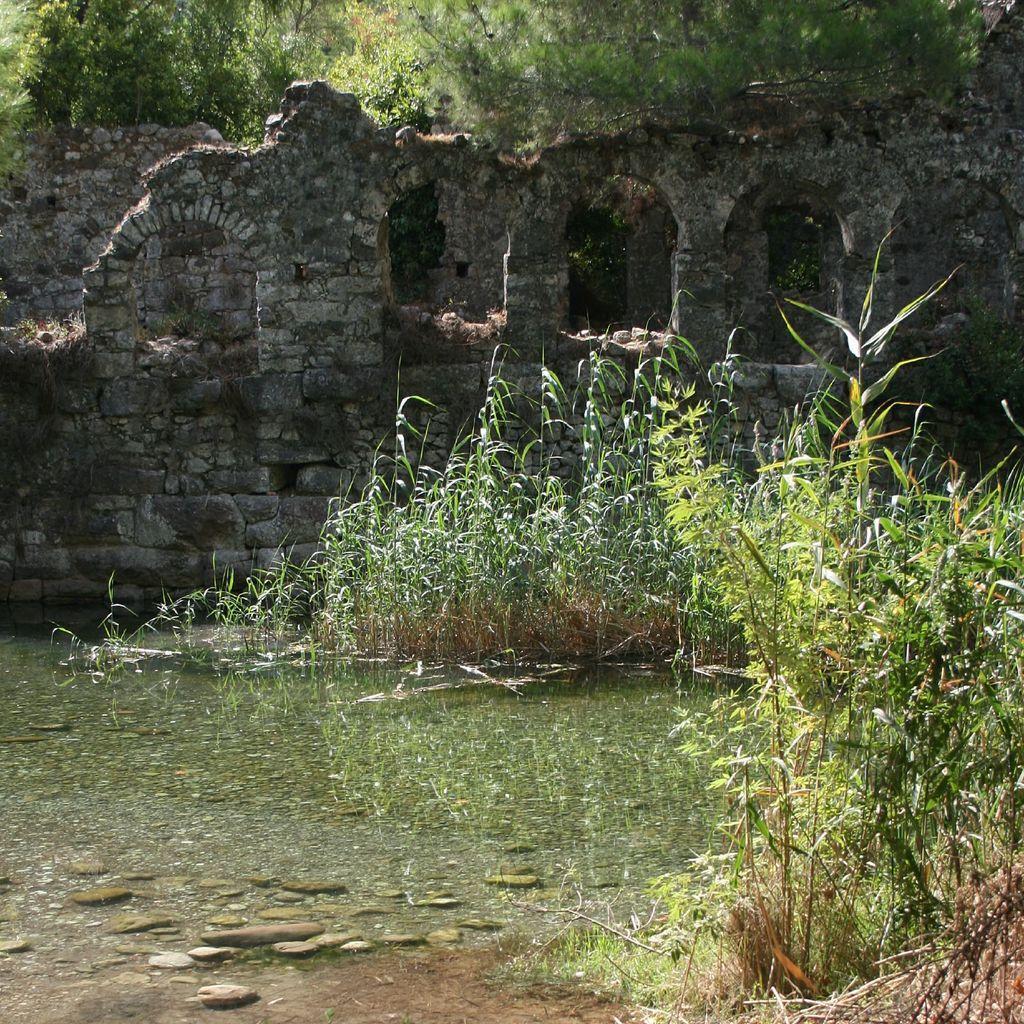How would you summarize this image in a sentence or two? In this image I can see the water. To the side of the water there are plants. In the back I can see the wall. In the background there are many trees. 